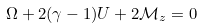<formula> <loc_0><loc_0><loc_500><loc_500>\Omega + 2 ( \gamma - 1 ) U + 2 \mathcal { M } _ { z } = 0</formula> 